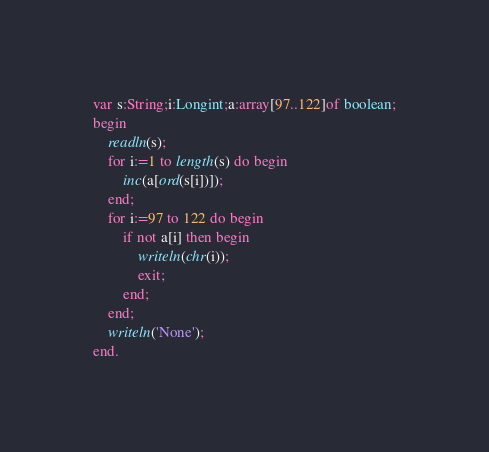Convert code to text. <code><loc_0><loc_0><loc_500><loc_500><_Pascal_>var s:String;i:Longint;a:array[97..122]of boolean;
begin
	readln(s);
	for i:=1 to length(s) do begin
		inc(a[ord(s[i])]);
	end;
	for i:=97 to 122 do begin
		if not a[i] then begin
			writeln(chr(i));
			exit;
		end;
	end;
	writeln('None');
end.
</code> 